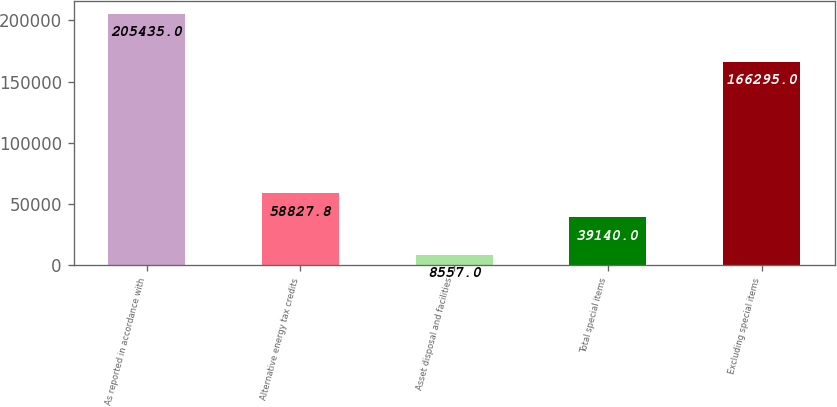Convert chart. <chart><loc_0><loc_0><loc_500><loc_500><bar_chart><fcel>As reported in accordance with<fcel>Alternative energy tax credits<fcel>Asset disposal and facilities<fcel>Total special items<fcel>Excluding special items<nl><fcel>205435<fcel>58827.8<fcel>8557<fcel>39140<fcel>166295<nl></chart> 